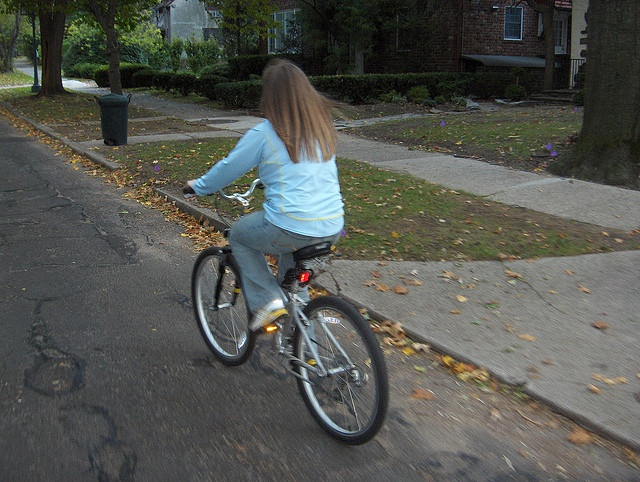Describe the objects in this image and their specific colors. I can see bicycle in black, gray, darkgray, and purple tones and people in black, gray, and lightblue tones in this image. 